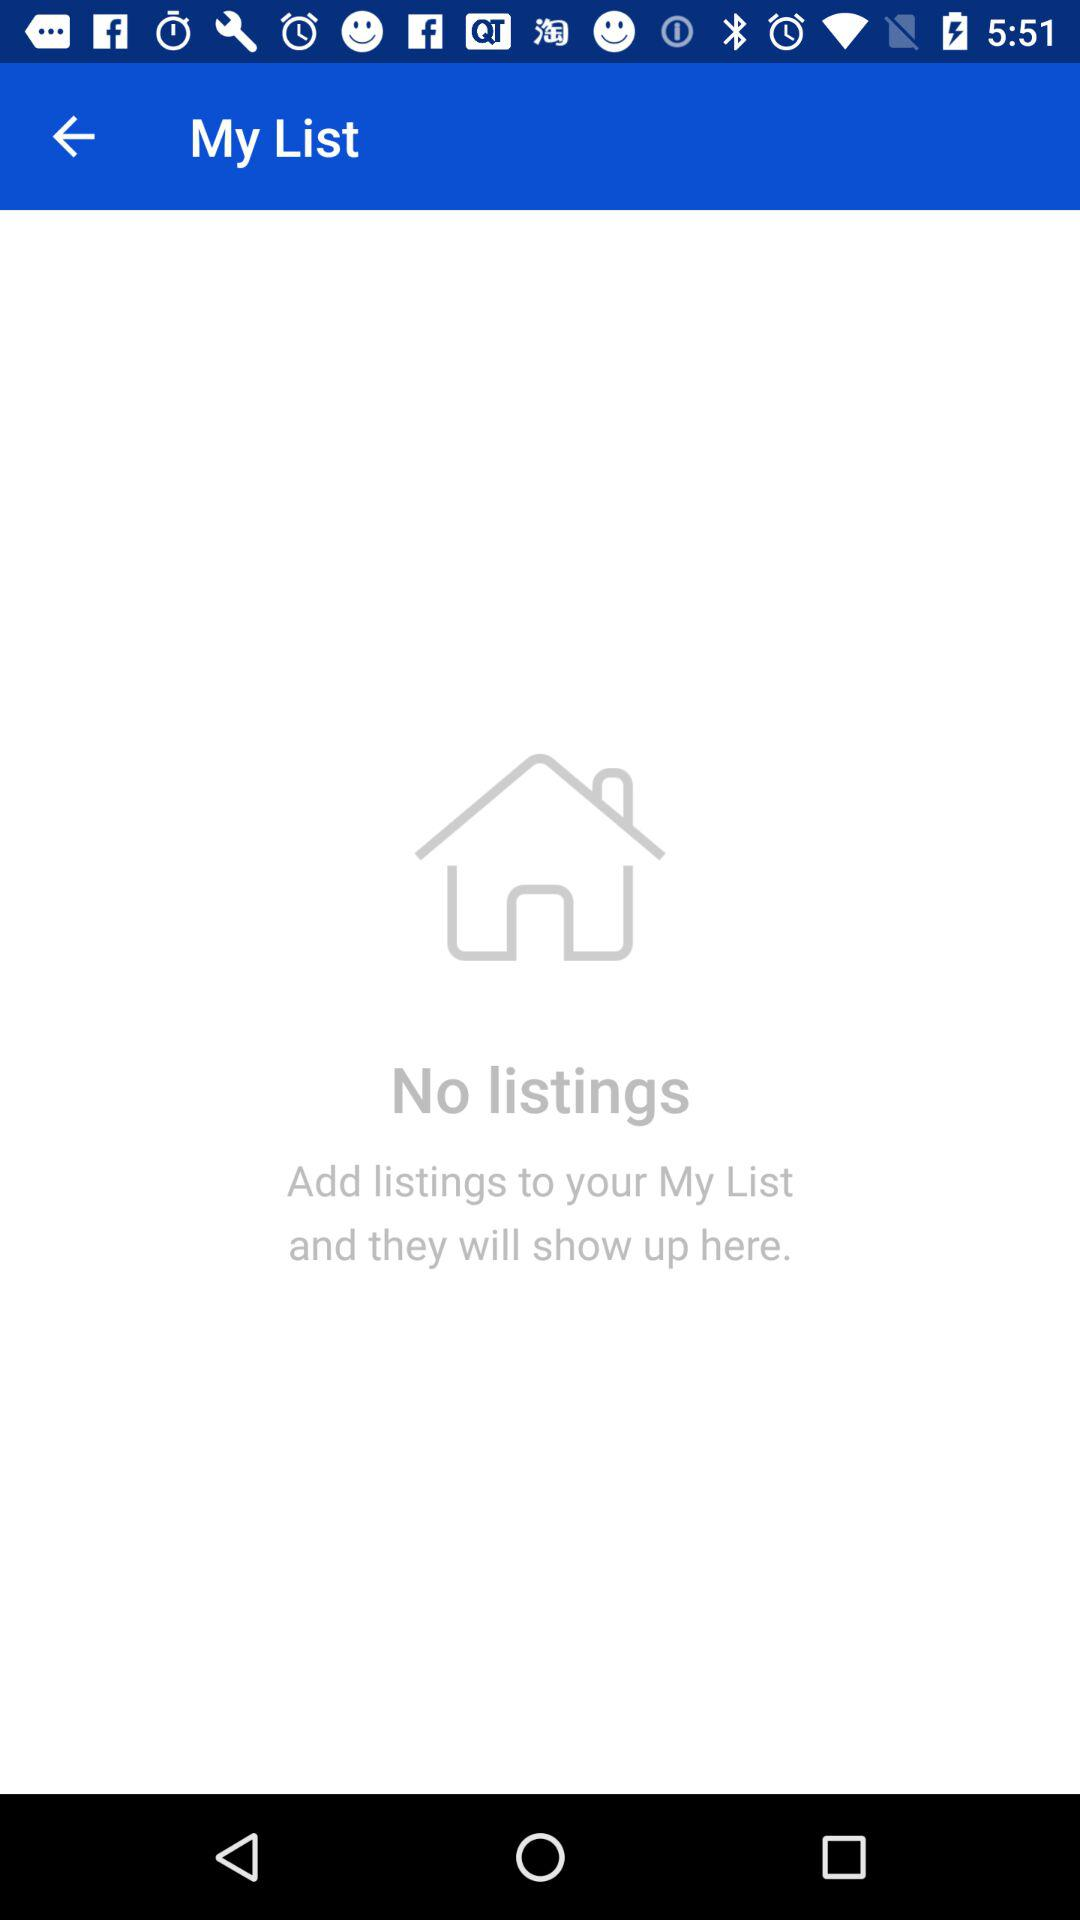How many listings are in the list? There are no listings in the list. 